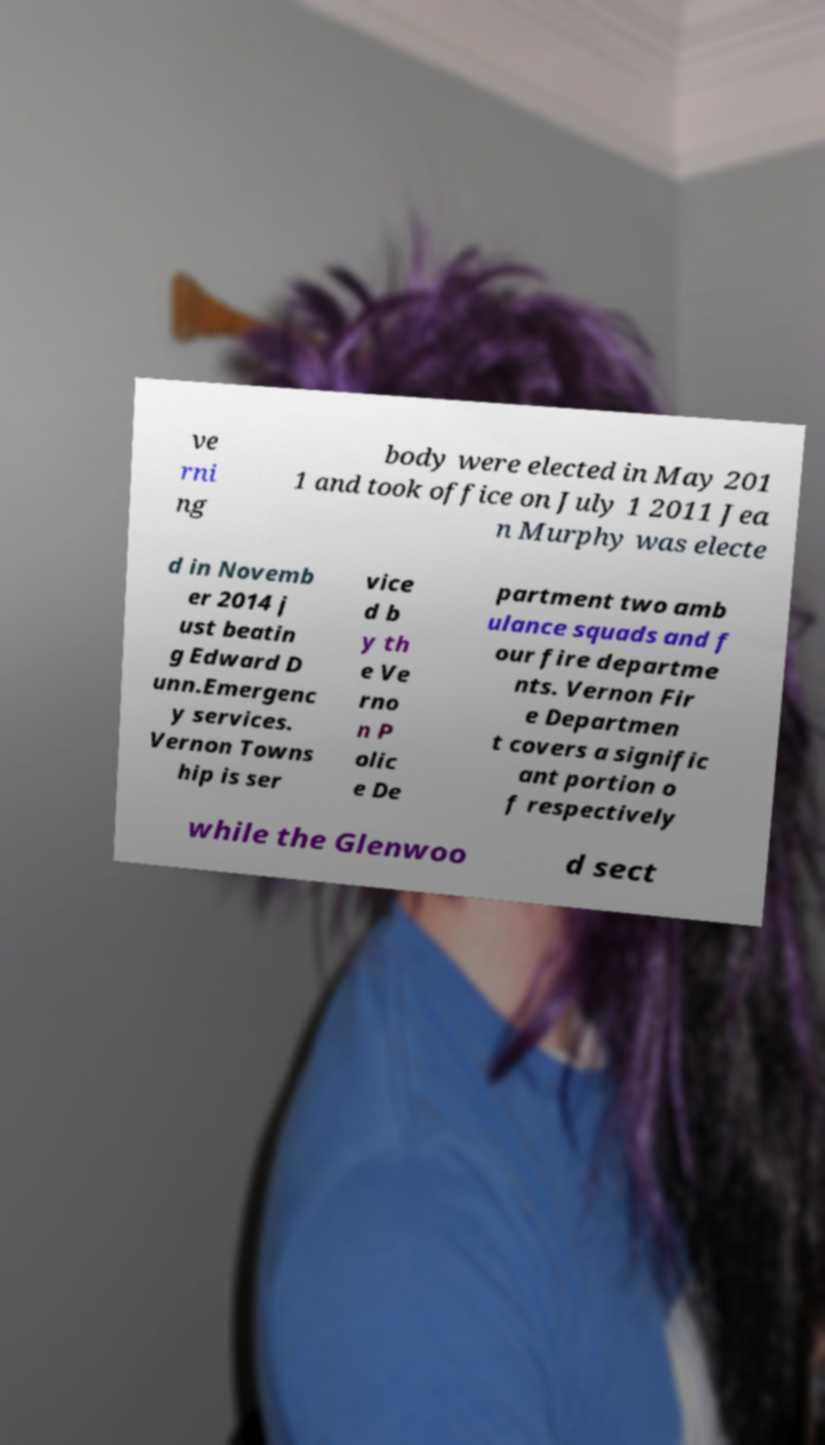Could you assist in decoding the text presented in this image and type it out clearly? ve rni ng body were elected in May 201 1 and took office on July 1 2011 Jea n Murphy was electe d in Novemb er 2014 j ust beatin g Edward D unn.Emergenc y services. Vernon Towns hip is ser vice d b y th e Ve rno n P olic e De partment two amb ulance squads and f our fire departme nts. Vernon Fir e Departmen t covers a signific ant portion o f respectively while the Glenwoo d sect 